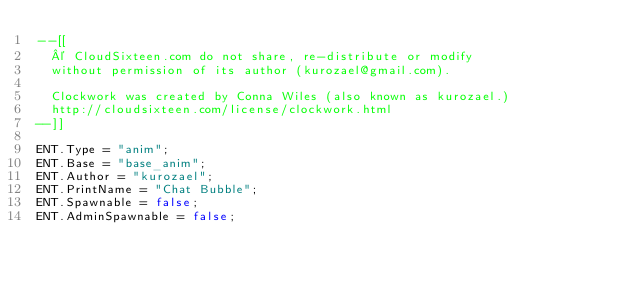Convert code to text. <code><loc_0><loc_0><loc_500><loc_500><_Lua_>--[[
	© CloudSixteen.com do not share, re-distribute or modify
	without permission of its author (kurozael@gmail.com).

	Clockwork was created by Conna Wiles (also known as kurozael.)
	http://cloudsixteen.com/license/clockwork.html
--]]

ENT.Type = "anim";
ENT.Base = "base_anim";
ENT.Author = "kurozael";
ENT.PrintName = "Chat Bubble";
ENT.Spawnable = false;
ENT.AdminSpawnable = false;</code> 